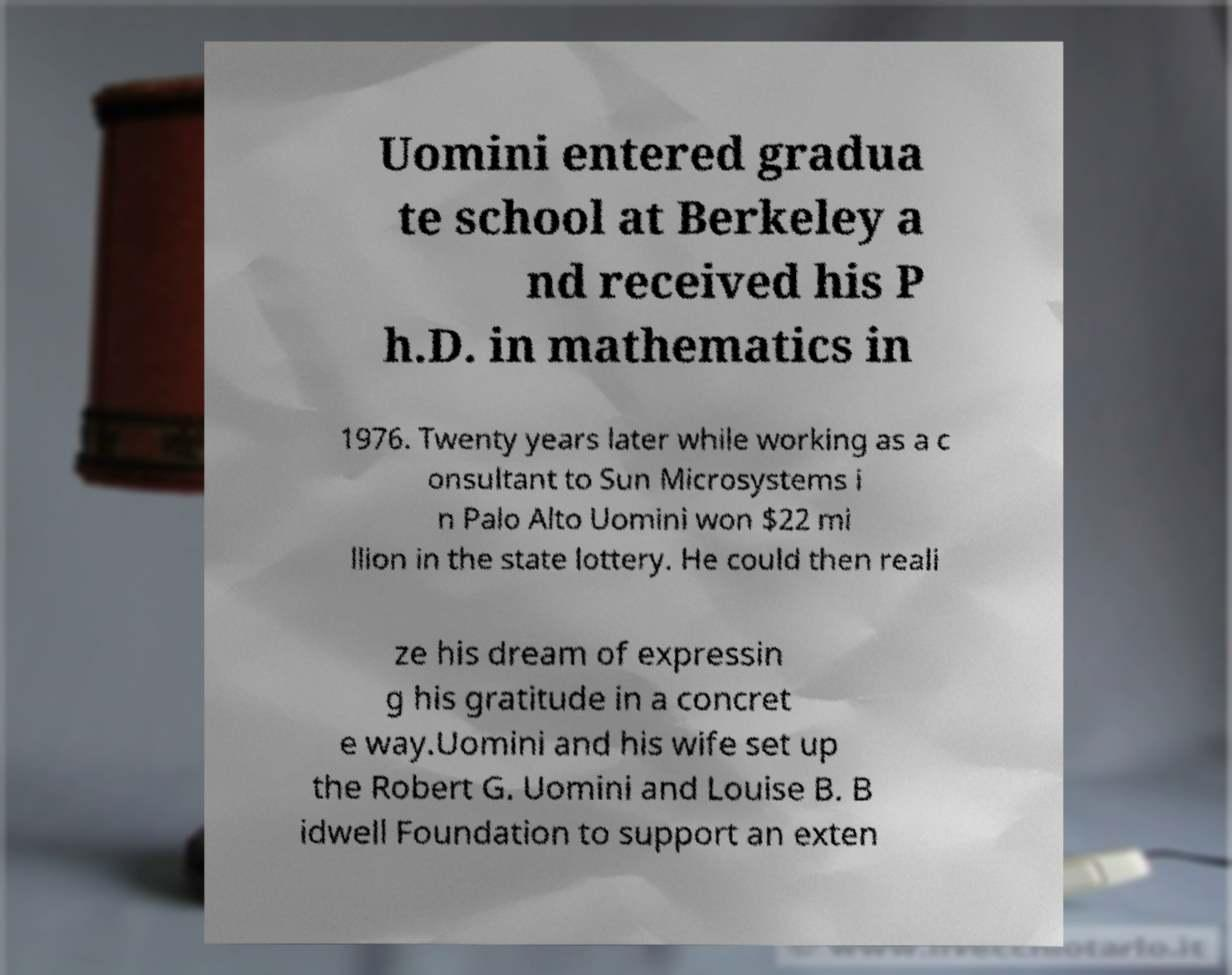Please read and relay the text visible in this image. What does it say? Uomini entered gradua te school at Berkeley a nd received his P h.D. in mathematics in 1976. Twenty years later while working as a c onsultant to Sun Microsystems i n Palo Alto Uomini won $22 mi llion in the state lottery. He could then reali ze his dream of expressin g his gratitude in a concret e way.Uomini and his wife set up the Robert G. Uomini and Louise B. B idwell Foundation to support an exten 